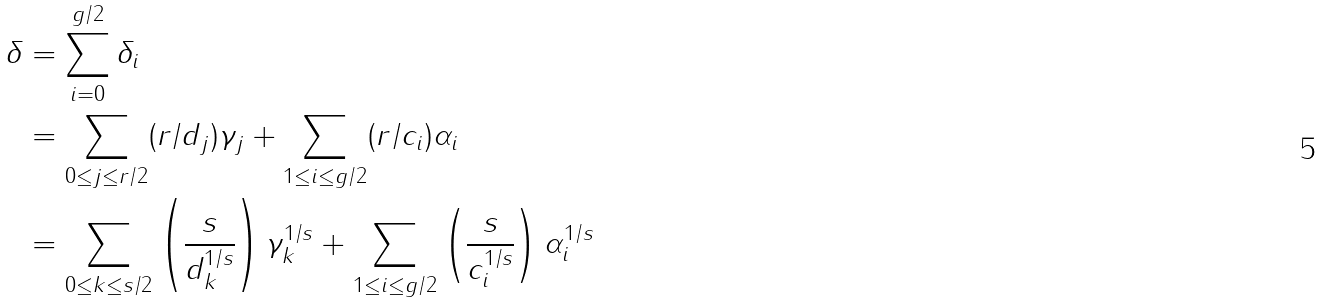Convert formula to latex. <formula><loc_0><loc_0><loc_500><loc_500>\delta & = \sum _ { i = 0 } ^ { g / 2 } \delta _ { i } \\ & = \sum _ { 0 \leq j \leq r / 2 } ( r / d _ { j } ) \gamma _ { j } + \sum _ { 1 \leq i \leq g / 2 } ( r / c _ { i } ) \alpha _ { i } \\ & = \sum _ { 0 \leq k \leq s / 2 } \left ( \frac { s } { d ^ { 1 / s } _ { k } } \right ) \gamma ^ { 1 / s } _ { k } + \sum _ { 1 \leq i \leq g / 2 } \left ( \frac { s } { c ^ { 1 / s } _ { i } } \right ) \alpha ^ { 1 / s } _ { i } \\</formula> 